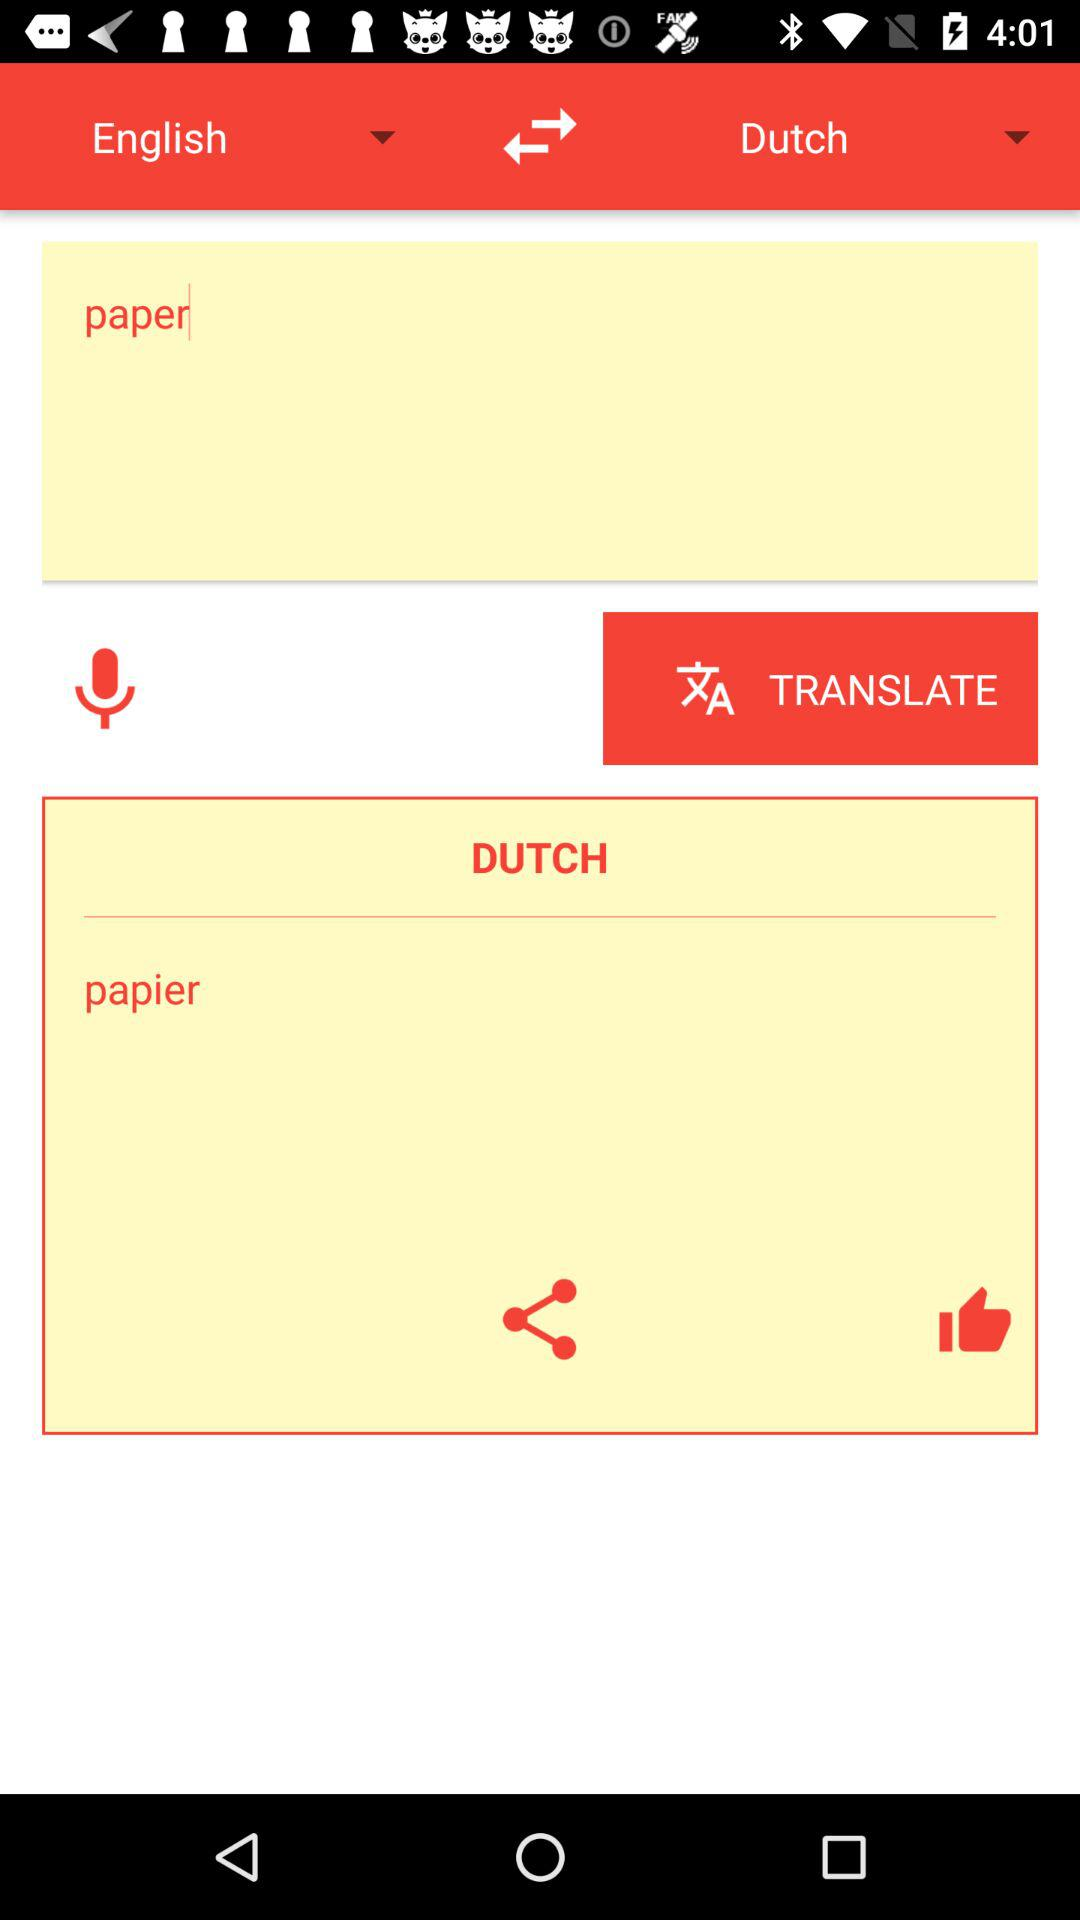In what language is the translation done? The translation is done in the Dutch language. 